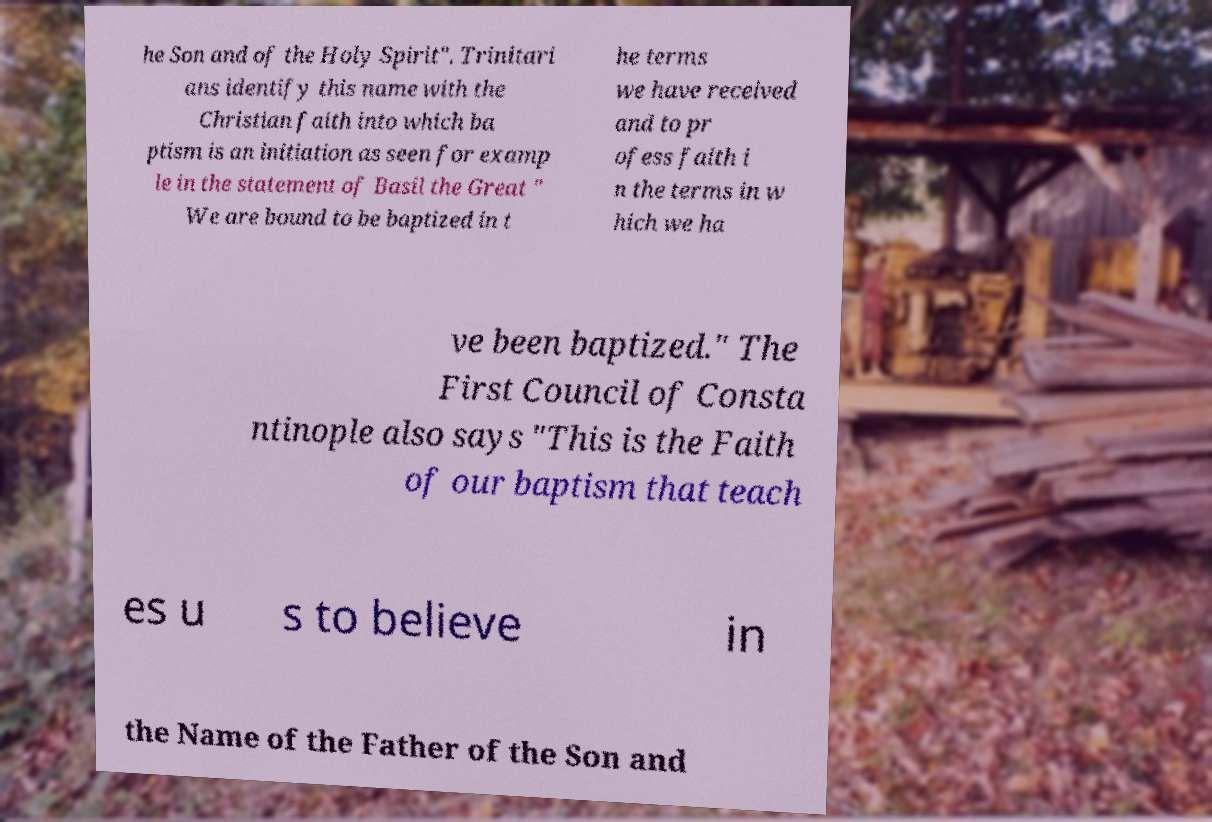Can you read and provide the text displayed in the image?This photo seems to have some interesting text. Can you extract and type it out for me? he Son and of the Holy Spirit". Trinitari ans identify this name with the Christian faith into which ba ptism is an initiation as seen for examp le in the statement of Basil the Great " We are bound to be baptized in t he terms we have received and to pr ofess faith i n the terms in w hich we ha ve been baptized." The First Council of Consta ntinople also says "This is the Faith of our baptism that teach es u s to believe in the Name of the Father of the Son and 